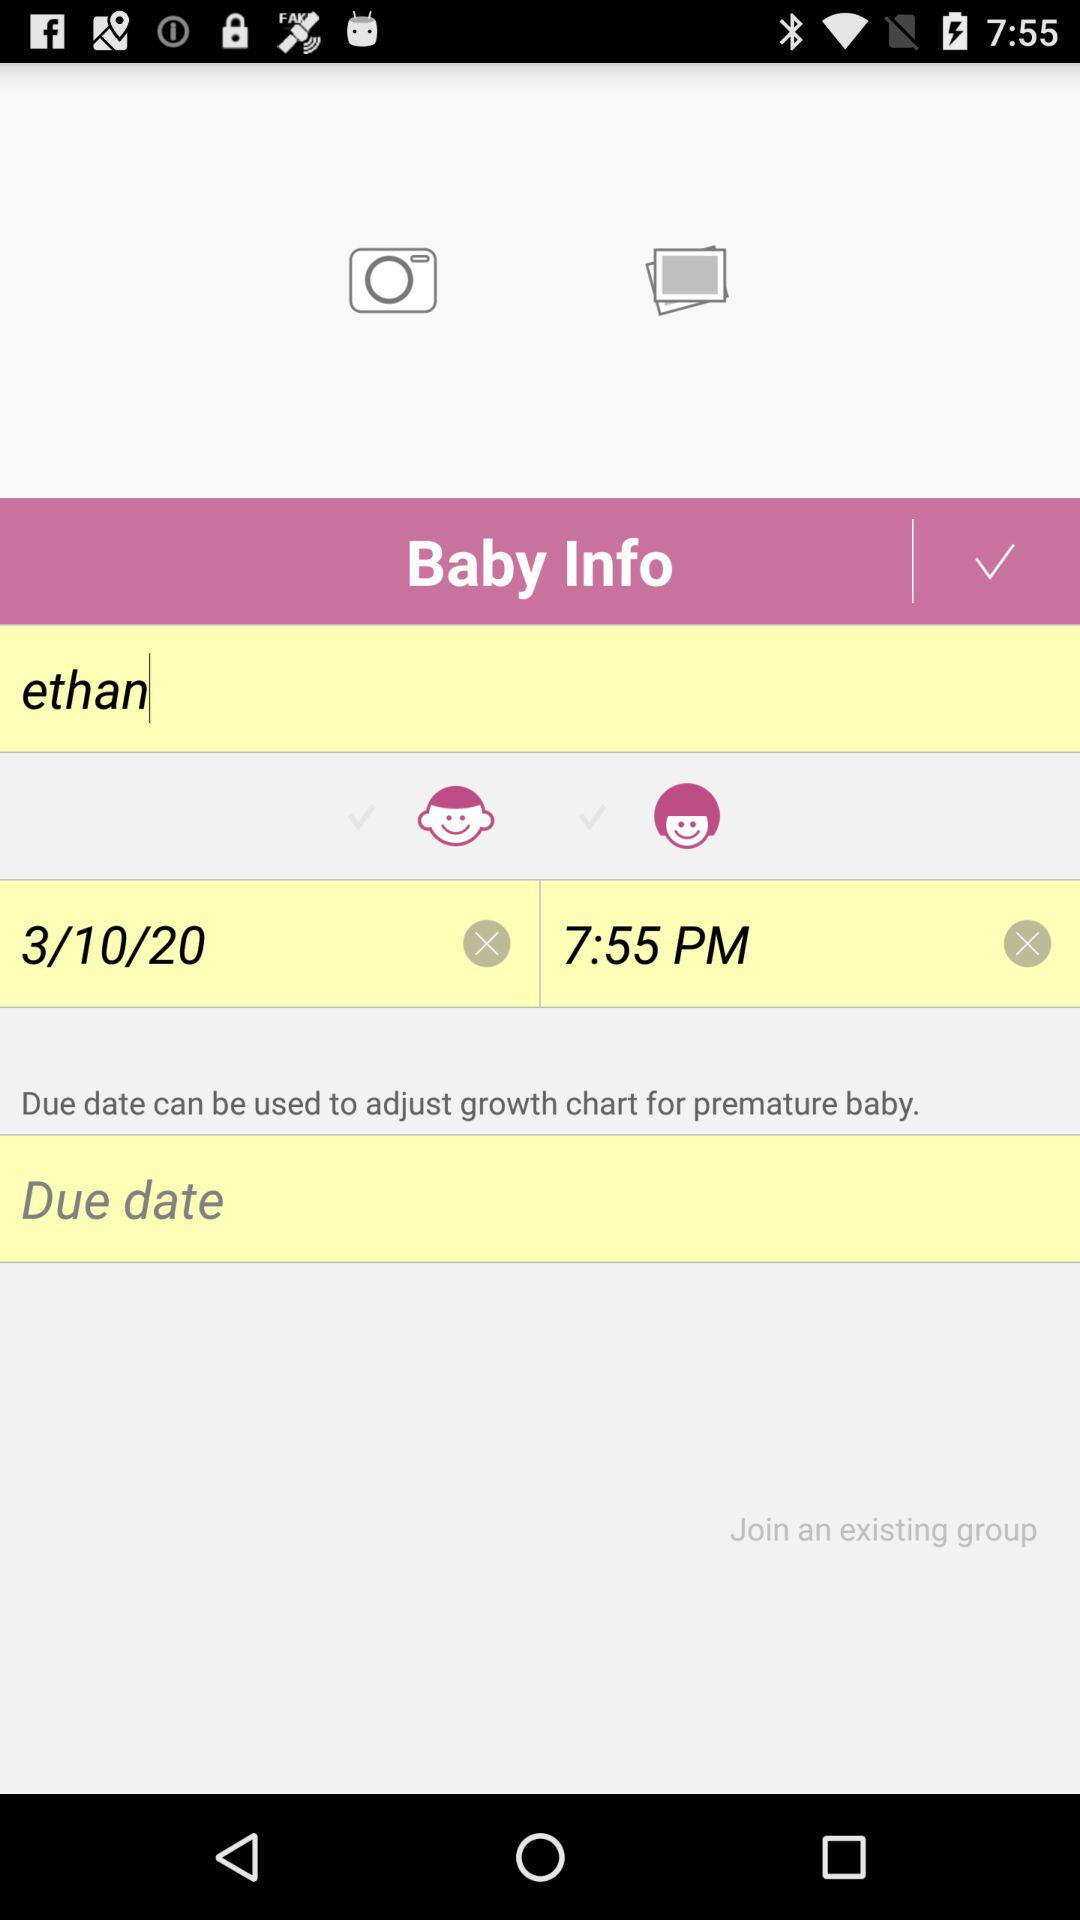What is the given time? The given time is 7:55 PM. 